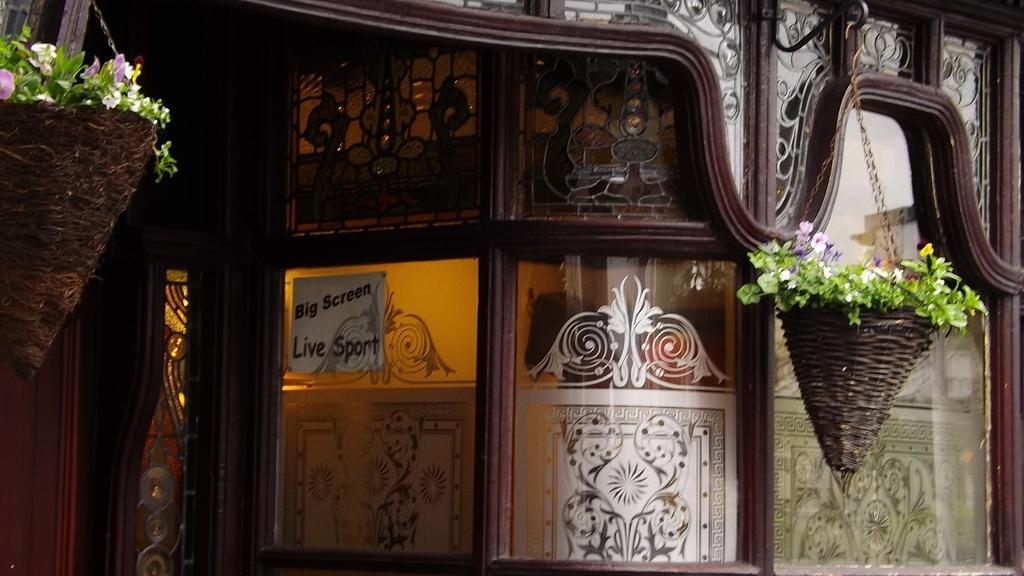Please provide a concise description of this image. In this picture we can see the posts containing the green leaves and flowers and the pots are hanging on the metal object and we can see some pictures on the glasses and we can see the text on the paper attached to the glass and we can see some other objects. 